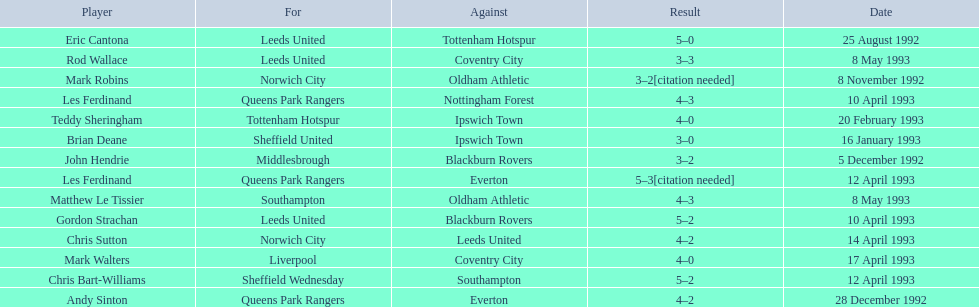Who are all the players? Eric Cantona, Mark Robins, John Hendrie, Andy Sinton, Brian Deane, Teddy Sheringham, Gordon Strachan, Les Ferdinand, Chris Bart-Williams, Les Ferdinand, Chris Sutton, Mark Walters, Rod Wallace, Matthew Le Tissier. What were their results? 5–0, 3–2[citation needed], 3–2, 4–2, 3–0, 4–0, 5–2, 4–3, 5–2, 5–3[citation needed], 4–2, 4–0, 3–3, 4–3. Which player tied with mark robins? John Hendrie. 